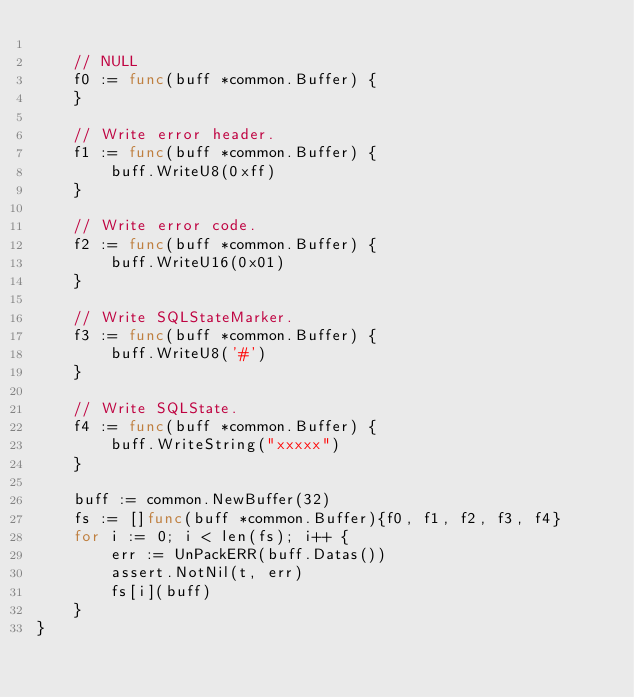<code> <loc_0><loc_0><loc_500><loc_500><_Go_>
	// NULL
	f0 := func(buff *common.Buffer) {
	}

	// Write error header.
	f1 := func(buff *common.Buffer) {
		buff.WriteU8(0xff)
	}

	// Write error code.
	f2 := func(buff *common.Buffer) {
		buff.WriteU16(0x01)
	}

	// Write SQLStateMarker.
	f3 := func(buff *common.Buffer) {
		buff.WriteU8('#')
	}

	// Write SQLState.
	f4 := func(buff *common.Buffer) {
		buff.WriteString("xxxxx")
	}

	buff := common.NewBuffer(32)
	fs := []func(buff *common.Buffer){f0, f1, f2, f3, f4}
	for i := 0; i < len(fs); i++ {
		err := UnPackERR(buff.Datas())
		assert.NotNil(t, err)
		fs[i](buff)
	}
}
</code> 